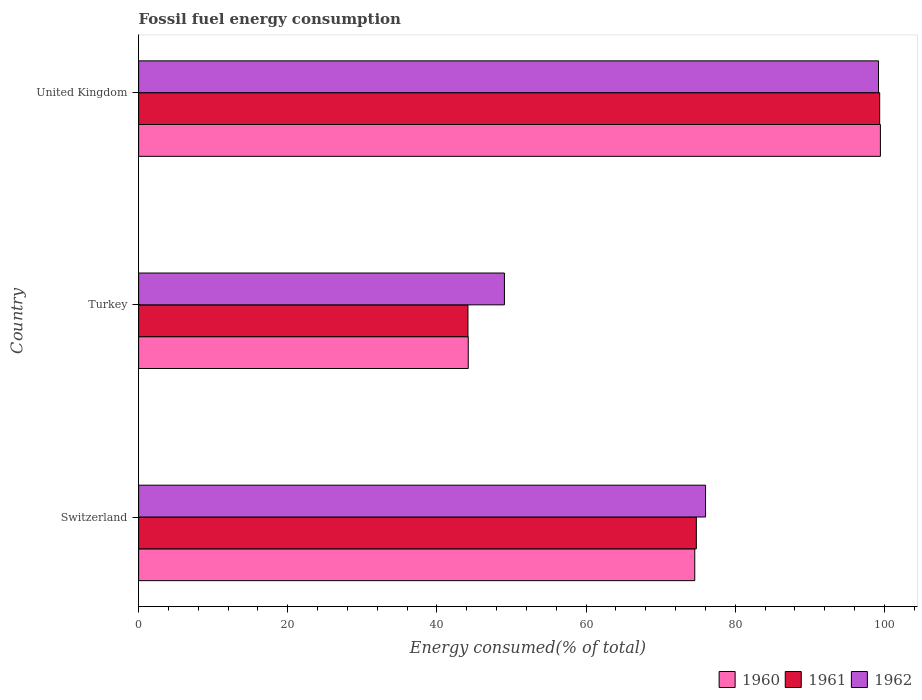How many different coloured bars are there?
Your answer should be compact. 3. How many groups of bars are there?
Your response must be concise. 3. Are the number of bars per tick equal to the number of legend labels?
Make the answer very short. Yes. Are the number of bars on each tick of the Y-axis equal?
Ensure brevity in your answer.  Yes. How many bars are there on the 2nd tick from the bottom?
Your answer should be compact. 3. What is the label of the 3rd group of bars from the top?
Keep it short and to the point. Switzerland. In how many cases, is the number of bars for a given country not equal to the number of legend labels?
Ensure brevity in your answer.  0. What is the percentage of energy consumed in 1962 in Switzerland?
Give a very brief answer. 76.02. Across all countries, what is the maximum percentage of energy consumed in 1960?
Provide a succinct answer. 99.46. Across all countries, what is the minimum percentage of energy consumed in 1960?
Your answer should be very brief. 44.2. In which country was the percentage of energy consumed in 1960 maximum?
Your answer should be very brief. United Kingdom. In which country was the percentage of energy consumed in 1962 minimum?
Provide a succinct answer. Turkey. What is the total percentage of energy consumed in 1961 in the graph?
Your response must be concise. 218.31. What is the difference between the percentage of energy consumed in 1962 in Switzerland and that in Turkey?
Provide a succinct answer. 26.97. What is the difference between the percentage of energy consumed in 1960 in Turkey and the percentage of energy consumed in 1962 in Switzerland?
Your answer should be very brief. -31.82. What is the average percentage of energy consumed in 1962 per country?
Ensure brevity in your answer.  74.76. What is the difference between the percentage of energy consumed in 1962 and percentage of energy consumed in 1961 in Turkey?
Provide a succinct answer. 4.89. In how many countries, is the percentage of energy consumed in 1962 greater than 4 %?
Make the answer very short. 3. What is the ratio of the percentage of energy consumed in 1960 in Switzerland to that in United Kingdom?
Provide a succinct answer. 0.75. What is the difference between the highest and the second highest percentage of energy consumed in 1961?
Ensure brevity in your answer.  24.58. What is the difference between the highest and the lowest percentage of energy consumed in 1960?
Ensure brevity in your answer.  55.27. In how many countries, is the percentage of energy consumed in 1961 greater than the average percentage of energy consumed in 1961 taken over all countries?
Your answer should be very brief. 2. Is it the case that in every country, the sum of the percentage of energy consumed in 1962 and percentage of energy consumed in 1960 is greater than the percentage of energy consumed in 1961?
Offer a terse response. Yes. Are all the bars in the graph horizontal?
Give a very brief answer. Yes. How many countries are there in the graph?
Your answer should be very brief. 3. What is the difference between two consecutive major ticks on the X-axis?
Your answer should be compact. 20. Where does the legend appear in the graph?
Your answer should be compact. Bottom right. How are the legend labels stacked?
Provide a short and direct response. Horizontal. What is the title of the graph?
Offer a terse response. Fossil fuel energy consumption. What is the label or title of the X-axis?
Offer a terse response. Energy consumed(% of total). What is the label or title of the Y-axis?
Provide a succinct answer. Country. What is the Energy consumed(% of total) in 1960 in Switzerland?
Keep it short and to the point. 74.57. What is the Energy consumed(% of total) of 1961 in Switzerland?
Your answer should be very brief. 74.78. What is the Energy consumed(% of total) in 1962 in Switzerland?
Ensure brevity in your answer.  76.02. What is the Energy consumed(% of total) of 1960 in Turkey?
Offer a very short reply. 44.2. What is the Energy consumed(% of total) in 1961 in Turkey?
Ensure brevity in your answer.  44.16. What is the Energy consumed(% of total) of 1962 in Turkey?
Your answer should be very brief. 49.05. What is the Energy consumed(% of total) in 1960 in United Kingdom?
Ensure brevity in your answer.  99.46. What is the Energy consumed(% of total) of 1961 in United Kingdom?
Give a very brief answer. 99.37. What is the Energy consumed(% of total) of 1962 in United Kingdom?
Ensure brevity in your answer.  99.21. Across all countries, what is the maximum Energy consumed(% of total) in 1960?
Your answer should be very brief. 99.46. Across all countries, what is the maximum Energy consumed(% of total) of 1961?
Keep it short and to the point. 99.37. Across all countries, what is the maximum Energy consumed(% of total) in 1962?
Keep it short and to the point. 99.21. Across all countries, what is the minimum Energy consumed(% of total) in 1960?
Ensure brevity in your answer.  44.2. Across all countries, what is the minimum Energy consumed(% of total) of 1961?
Your response must be concise. 44.16. Across all countries, what is the minimum Energy consumed(% of total) in 1962?
Your response must be concise. 49.05. What is the total Energy consumed(% of total) in 1960 in the graph?
Ensure brevity in your answer.  218.24. What is the total Energy consumed(% of total) of 1961 in the graph?
Offer a terse response. 218.31. What is the total Energy consumed(% of total) in 1962 in the graph?
Keep it short and to the point. 224.28. What is the difference between the Energy consumed(% of total) of 1960 in Switzerland and that in Turkey?
Give a very brief answer. 30.37. What is the difference between the Energy consumed(% of total) in 1961 in Switzerland and that in Turkey?
Offer a terse response. 30.62. What is the difference between the Energy consumed(% of total) of 1962 in Switzerland and that in Turkey?
Ensure brevity in your answer.  26.97. What is the difference between the Energy consumed(% of total) of 1960 in Switzerland and that in United Kingdom?
Your answer should be compact. -24.89. What is the difference between the Energy consumed(% of total) of 1961 in Switzerland and that in United Kingdom?
Offer a very short reply. -24.58. What is the difference between the Energy consumed(% of total) of 1962 in Switzerland and that in United Kingdom?
Your answer should be compact. -23.19. What is the difference between the Energy consumed(% of total) in 1960 in Turkey and that in United Kingdom?
Ensure brevity in your answer.  -55.27. What is the difference between the Energy consumed(% of total) of 1961 in Turkey and that in United Kingdom?
Provide a succinct answer. -55.21. What is the difference between the Energy consumed(% of total) of 1962 in Turkey and that in United Kingdom?
Make the answer very short. -50.16. What is the difference between the Energy consumed(% of total) of 1960 in Switzerland and the Energy consumed(% of total) of 1961 in Turkey?
Offer a terse response. 30.41. What is the difference between the Energy consumed(% of total) of 1960 in Switzerland and the Energy consumed(% of total) of 1962 in Turkey?
Give a very brief answer. 25.52. What is the difference between the Energy consumed(% of total) in 1961 in Switzerland and the Energy consumed(% of total) in 1962 in Turkey?
Offer a very short reply. 25.73. What is the difference between the Energy consumed(% of total) in 1960 in Switzerland and the Energy consumed(% of total) in 1961 in United Kingdom?
Keep it short and to the point. -24.8. What is the difference between the Energy consumed(% of total) of 1960 in Switzerland and the Energy consumed(% of total) of 1962 in United Kingdom?
Your answer should be very brief. -24.64. What is the difference between the Energy consumed(% of total) in 1961 in Switzerland and the Energy consumed(% of total) in 1962 in United Kingdom?
Your response must be concise. -24.42. What is the difference between the Energy consumed(% of total) in 1960 in Turkey and the Energy consumed(% of total) in 1961 in United Kingdom?
Provide a succinct answer. -55.17. What is the difference between the Energy consumed(% of total) of 1960 in Turkey and the Energy consumed(% of total) of 1962 in United Kingdom?
Offer a very short reply. -55.01. What is the difference between the Energy consumed(% of total) of 1961 in Turkey and the Energy consumed(% of total) of 1962 in United Kingdom?
Give a very brief answer. -55.05. What is the average Energy consumed(% of total) of 1960 per country?
Offer a very short reply. 72.75. What is the average Energy consumed(% of total) in 1961 per country?
Your answer should be compact. 72.77. What is the average Energy consumed(% of total) in 1962 per country?
Give a very brief answer. 74.76. What is the difference between the Energy consumed(% of total) in 1960 and Energy consumed(% of total) in 1961 in Switzerland?
Ensure brevity in your answer.  -0.21. What is the difference between the Energy consumed(% of total) in 1960 and Energy consumed(% of total) in 1962 in Switzerland?
Provide a succinct answer. -1.45. What is the difference between the Energy consumed(% of total) in 1961 and Energy consumed(% of total) in 1962 in Switzerland?
Ensure brevity in your answer.  -1.23. What is the difference between the Energy consumed(% of total) in 1960 and Energy consumed(% of total) in 1962 in Turkey?
Provide a short and direct response. -4.85. What is the difference between the Energy consumed(% of total) of 1961 and Energy consumed(% of total) of 1962 in Turkey?
Give a very brief answer. -4.89. What is the difference between the Energy consumed(% of total) in 1960 and Energy consumed(% of total) in 1961 in United Kingdom?
Make the answer very short. 0.1. What is the difference between the Energy consumed(% of total) of 1960 and Energy consumed(% of total) of 1962 in United Kingdom?
Make the answer very short. 0.26. What is the difference between the Energy consumed(% of total) of 1961 and Energy consumed(% of total) of 1962 in United Kingdom?
Provide a short and direct response. 0.16. What is the ratio of the Energy consumed(% of total) in 1960 in Switzerland to that in Turkey?
Provide a succinct answer. 1.69. What is the ratio of the Energy consumed(% of total) in 1961 in Switzerland to that in Turkey?
Offer a terse response. 1.69. What is the ratio of the Energy consumed(% of total) of 1962 in Switzerland to that in Turkey?
Your answer should be very brief. 1.55. What is the ratio of the Energy consumed(% of total) of 1960 in Switzerland to that in United Kingdom?
Your answer should be very brief. 0.75. What is the ratio of the Energy consumed(% of total) of 1961 in Switzerland to that in United Kingdom?
Offer a terse response. 0.75. What is the ratio of the Energy consumed(% of total) of 1962 in Switzerland to that in United Kingdom?
Ensure brevity in your answer.  0.77. What is the ratio of the Energy consumed(% of total) in 1960 in Turkey to that in United Kingdom?
Your answer should be compact. 0.44. What is the ratio of the Energy consumed(% of total) of 1961 in Turkey to that in United Kingdom?
Give a very brief answer. 0.44. What is the ratio of the Energy consumed(% of total) of 1962 in Turkey to that in United Kingdom?
Your response must be concise. 0.49. What is the difference between the highest and the second highest Energy consumed(% of total) in 1960?
Make the answer very short. 24.89. What is the difference between the highest and the second highest Energy consumed(% of total) of 1961?
Give a very brief answer. 24.58. What is the difference between the highest and the second highest Energy consumed(% of total) of 1962?
Your answer should be compact. 23.19. What is the difference between the highest and the lowest Energy consumed(% of total) in 1960?
Offer a very short reply. 55.27. What is the difference between the highest and the lowest Energy consumed(% of total) of 1961?
Provide a succinct answer. 55.21. What is the difference between the highest and the lowest Energy consumed(% of total) in 1962?
Offer a terse response. 50.16. 